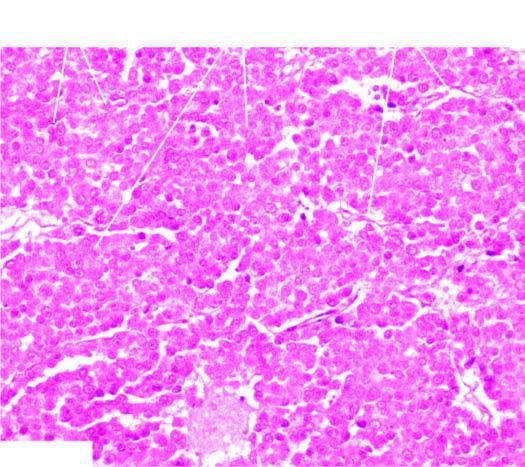what is the histologic appearance identical to?
Answer the question using a single word or phrase. That of seminoma of the testis 